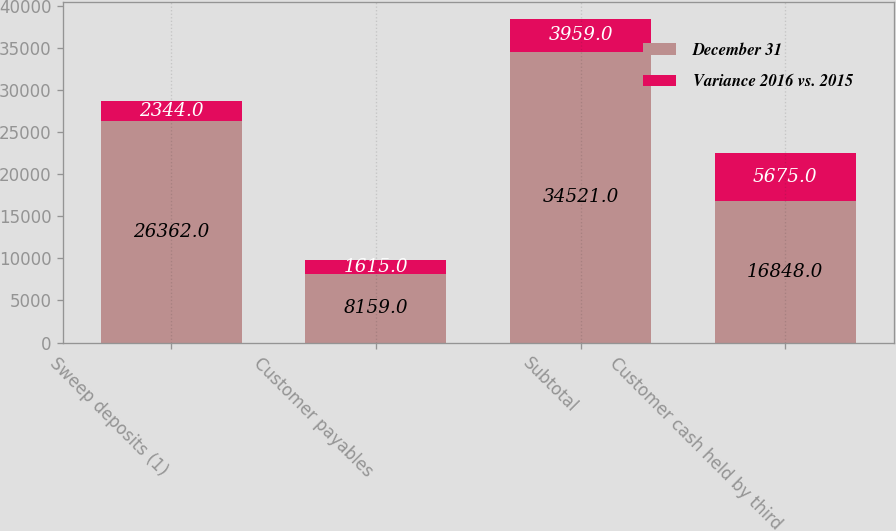Convert chart. <chart><loc_0><loc_0><loc_500><loc_500><stacked_bar_chart><ecel><fcel>Sweep deposits (1)<fcel>Customer payables<fcel>Subtotal<fcel>Customer cash held by third<nl><fcel>December 31<fcel>26362<fcel>8159<fcel>34521<fcel>16848<nl><fcel>Variance 2016 vs. 2015<fcel>2344<fcel>1615<fcel>3959<fcel>5675<nl></chart> 